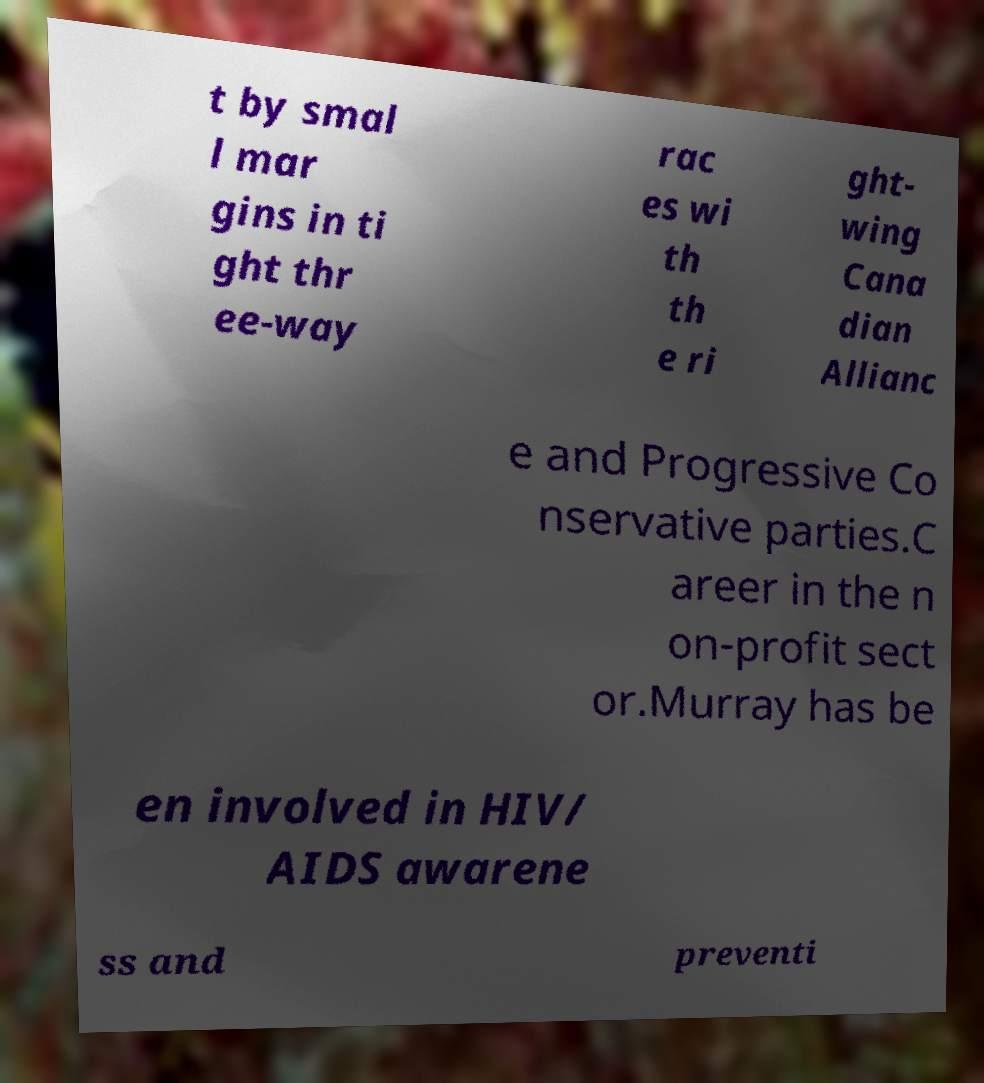Please identify and transcribe the text found in this image. t by smal l mar gins in ti ght thr ee-way rac es wi th th e ri ght- wing Cana dian Allianc e and Progressive Co nservative parties.C areer in the n on-profit sect or.Murray has be en involved in HIV/ AIDS awarene ss and preventi 